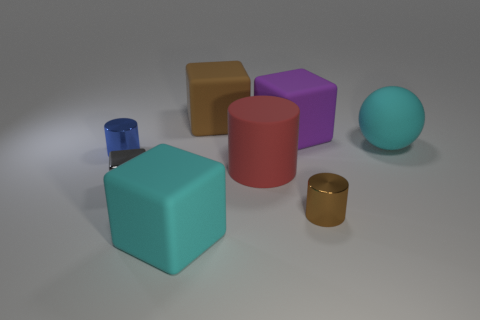The metallic block has what color?
Make the answer very short. Gray. What color is the metallic object that is the same shape as the brown matte object?
Give a very brief answer. Gray. How many purple matte objects are the same shape as the small blue shiny object?
Provide a short and direct response. 0. What number of objects are small brown metal objects or cubes that are behind the small gray shiny cube?
Provide a short and direct response. 3. There is a rubber cylinder; is it the same color as the large block to the right of the big brown block?
Your answer should be compact. No. What size is the matte thing that is both to the left of the large red matte cylinder and in front of the purple block?
Your response must be concise. Large. Are there any big brown matte objects right of the tiny brown metal cylinder?
Ensure brevity in your answer.  No. Is there a shiny thing that is right of the big cyan rubber object in front of the cyan rubber sphere?
Give a very brief answer. Yes. Are there the same number of big red rubber objects that are on the left side of the big cyan block and cubes that are to the right of the cyan matte ball?
Offer a terse response. Yes. There is a large cylinder that is made of the same material as the cyan cube; what color is it?
Keep it short and to the point. Red. 